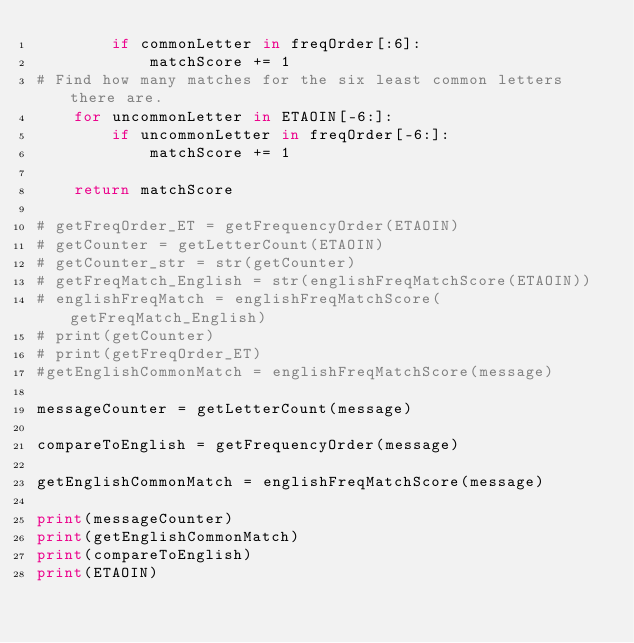Convert code to text. <code><loc_0><loc_0><loc_500><loc_500><_Python_>        if commonLetter in freqOrder[:6]:
            matchScore += 1
# Find how many matches for the six least common letters there are.
    for uncommonLetter in ETAOIN[-6:]:
        if uncommonLetter in freqOrder[-6:]:
            matchScore += 1
            
    return matchScore

# getFreqOrder_ET = getFrequencyOrder(ETAOIN)
# getCounter = getLetterCount(ETAOIN)
# getCounter_str = str(getCounter)
# getFreqMatch_English = str(englishFreqMatchScore(ETAOIN))
# englishFreqMatch = englishFreqMatchScore(getFreqMatch_English)
# print(getCounter)
# print(getFreqOrder_ET)
#getEnglishCommonMatch = englishFreqMatchScore(message)

messageCounter = getLetterCount(message)

compareToEnglish = getFrequencyOrder(message)

getEnglishCommonMatch = englishFreqMatchScore(message)

print(messageCounter)
print(getEnglishCommonMatch)
print(compareToEnglish)
print(ETAOIN)





</code> 